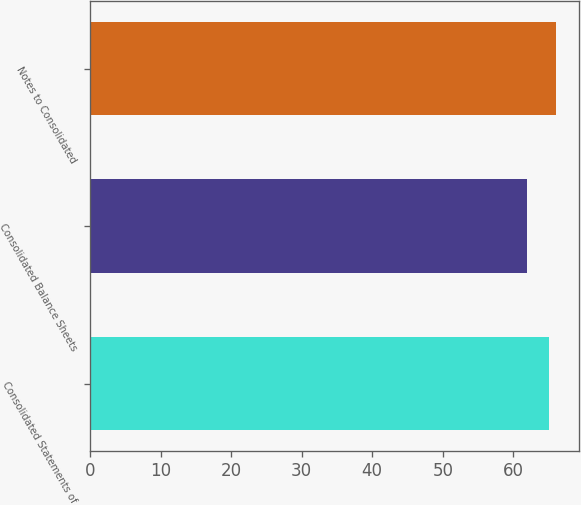Convert chart. <chart><loc_0><loc_0><loc_500><loc_500><bar_chart><fcel>Consolidated Statements of<fcel>Consolidated Balance Sheets<fcel>Notes to Consolidated<nl><fcel>65<fcel>62<fcel>66<nl></chart> 